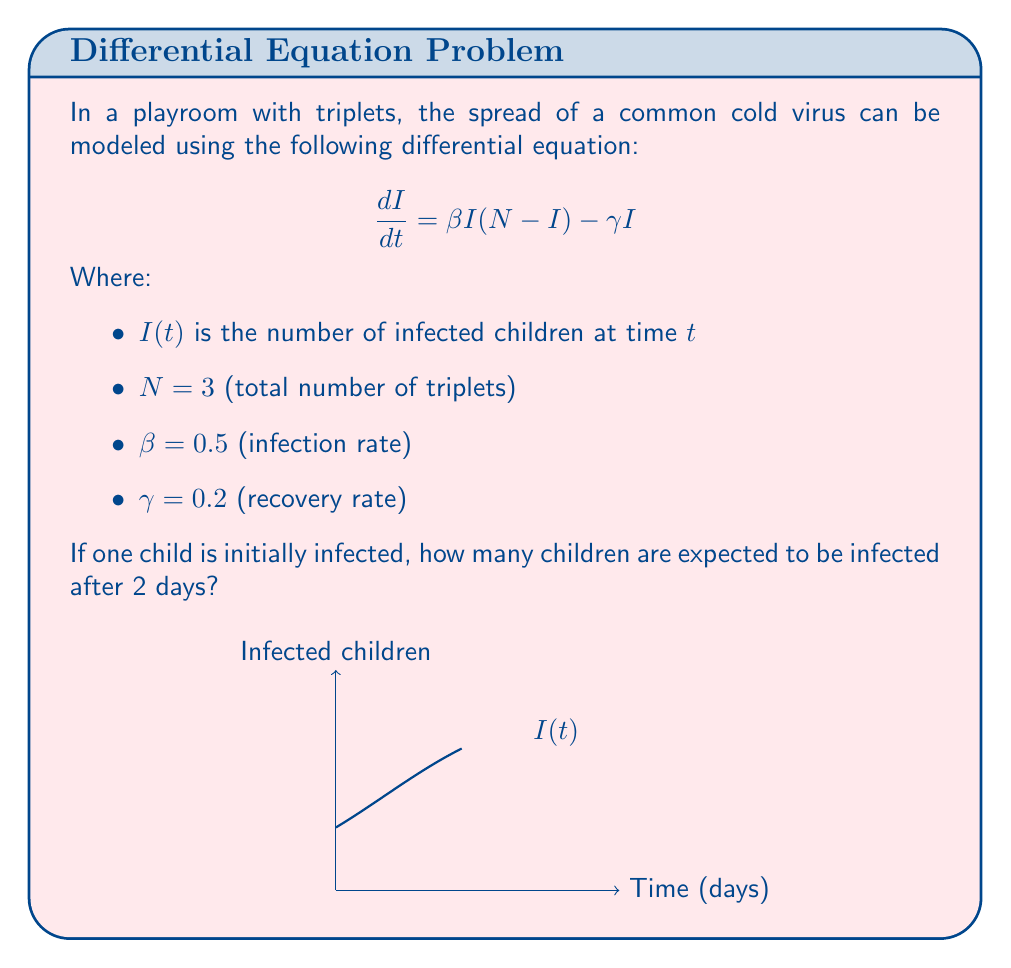Provide a solution to this math problem. Let's solve this step-by-step:

1) The given differential equation is a logistic growth model with recovery:

   $$\frac{dI}{dt} = \beta I(N-I) - \gamma I$$

2) Substituting the given values:

   $$\frac{dI}{dt} = 0.5I(3-I) - 0.2I = 1.5I - 0.5I^2 - 0.2I = 1.3I - 0.5I^2$$

3) This is a separable differential equation. We can solve it as follows:

   $$\int \frac{dI}{I(1.3 - 0.5I)} = \int dt$$

4) The left-hand side can be solved using partial fractions:

   $$\frac{1}{1.3} \ln|I| - \frac{1}{2.6} \ln|1.3 - 0.5I| = t + C$$

5) Using the initial condition $I(0) = 1$, we can find $C$:

   $$C = \frac{1}{1.3} \ln(1) - \frac{1}{2.6} \ln(0.8) = 0.1699$$

6) The solution is:

   $$I(t) = \frac{3.9}{1 + 2e^{-0.9t}}$$

7) To find $I(2)$, we substitute $t=2$:

   $$I(2) = \frac{3.9}{1 + 2e^{-1.8}} \approx 2.76$$
Answer: 2.76 children 